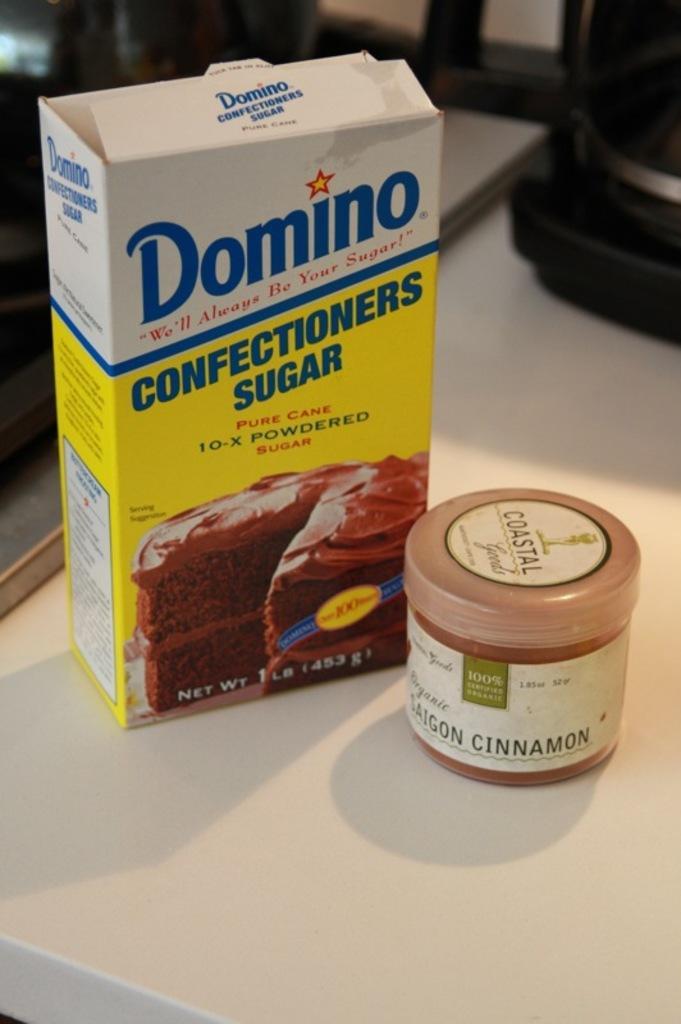Please provide a concise description of this image. In this picture I can observe white and yellow color box placed on the table. On the right side I can observe small container which is in cream and white color. The background is blurred. 